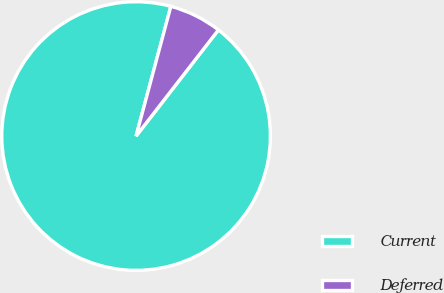Convert chart to OTSL. <chart><loc_0><loc_0><loc_500><loc_500><pie_chart><fcel>Current<fcel>Deferred<nl><fcel>93.67%<fcel>6.33%<nl></chart> 